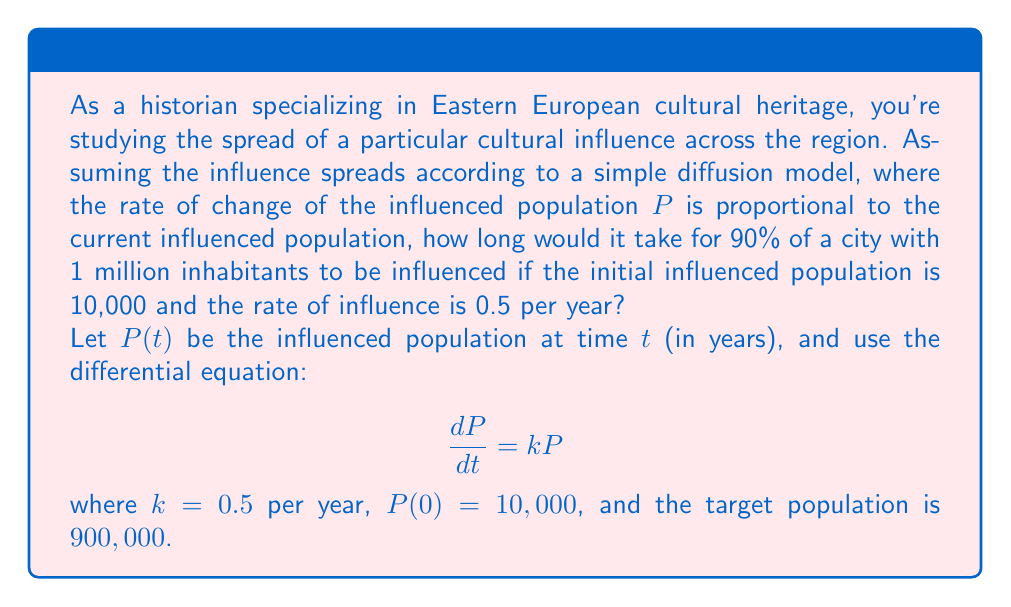What is the answer to this math problem? Let's solve this problem step by step:

1) The given differential equation is:
   $$\frac{dP}{dt} = kP$$
   where $k = 0.5$ per year

2) This is a separable equation. Rearranging it:
   $$\frac{dP}{P} = k dt$$

3) Integrating both sides:
   $$\int \frac{dP}{P} = \int k dt$$
   $$\ln|P| = kt + C$$

4) Solving for $P$:
   $$P = e^{kt + C} = Ae^{kt}$$
   where $A = e^C$

5) Using the initial condition $P(0) = 10,000$:
   $$10,000 = Ae^{0} = A$$

6) So our solution is:
   $$P(t) = 10,000e^{0.5t}$$

7) We want to find $t$ when $P(t) = 900,000$:
   $$900,000 = 10,000e^{0.5t}$$

8) Dividing both sides by 10,000:
   $$90 = e^{0.5t}$$

9) Taking the natural log of both sides:
   $$\ln(90) = 0.5t$$

10) Solving for $t$:
    $$t = \frac{\ln(90)}{0.5} \approx 8.98$$

Therefore, it would take approximately 8.98 years for 90% of the city's population to be influenced.
Answer: 8.98 years 